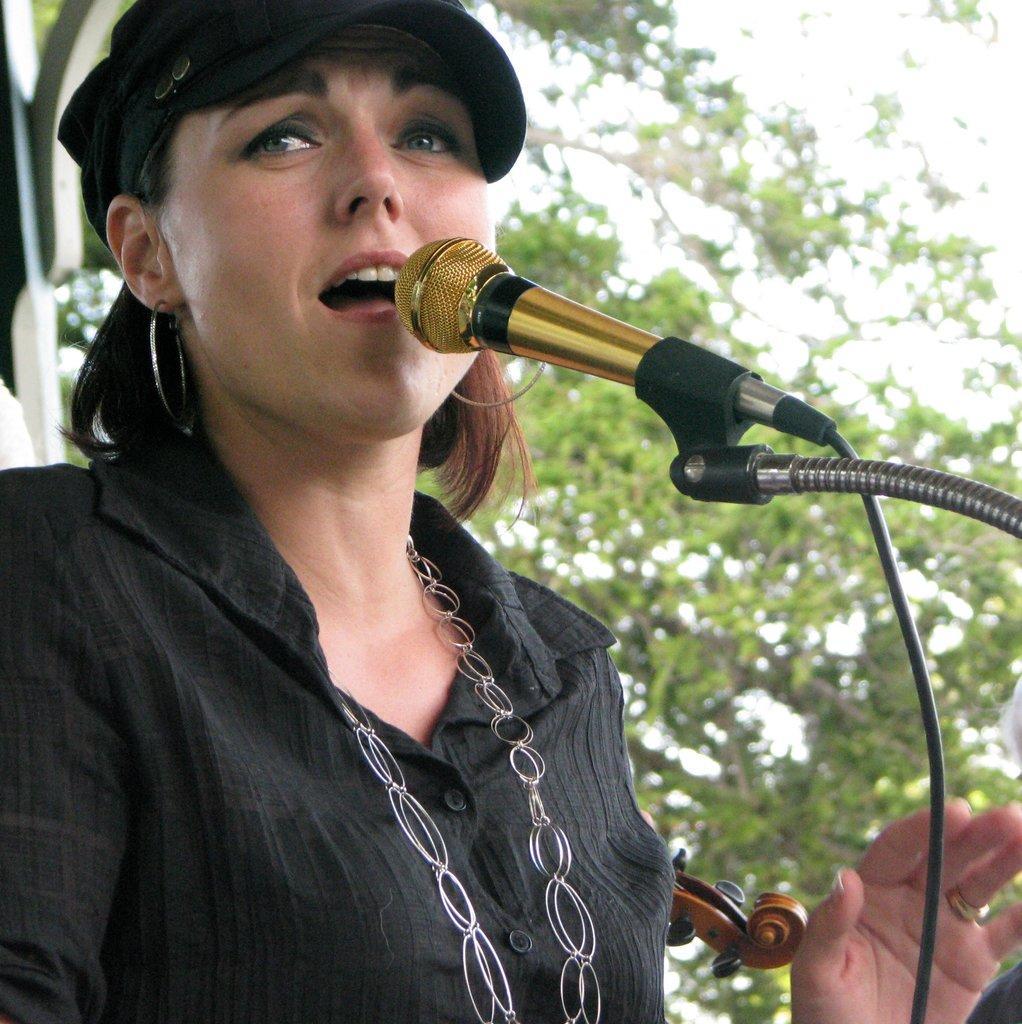In one or two sentences, can you explain what this image depicts? In this image I can see a woman is standing in front of a mike may be singing. In the background I can see a musical instrument, metal rods, trees and the sky. This image is taken may be during a sunny day. 